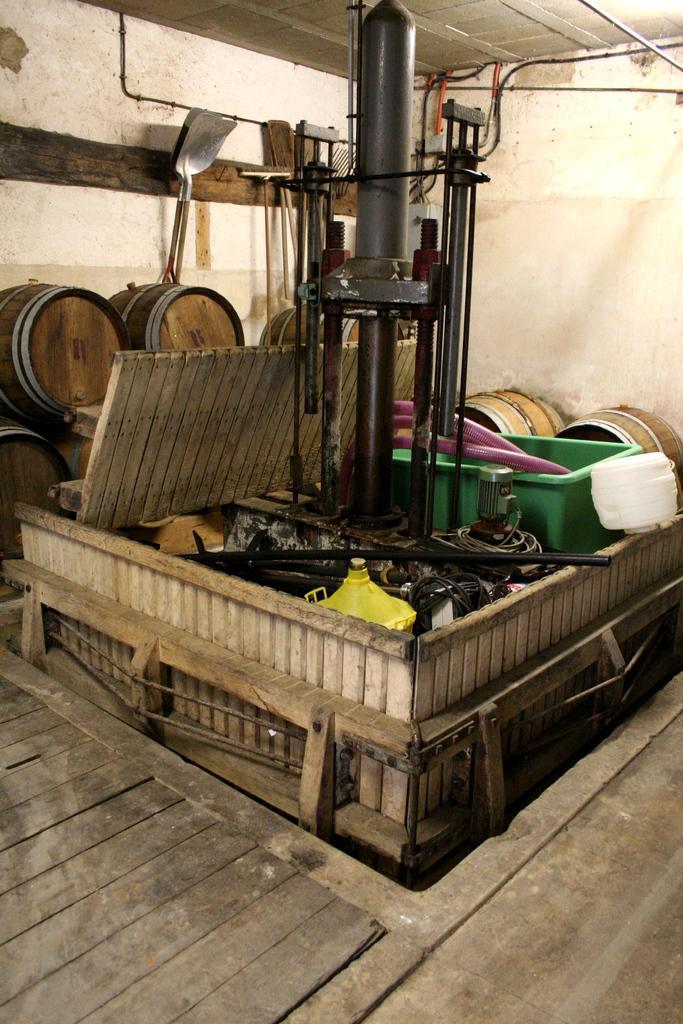Could you give a brief overview of what you see in this image? In this image I see an equipment over here and I see the floor. In the background I see few barrels and I see the wall. 